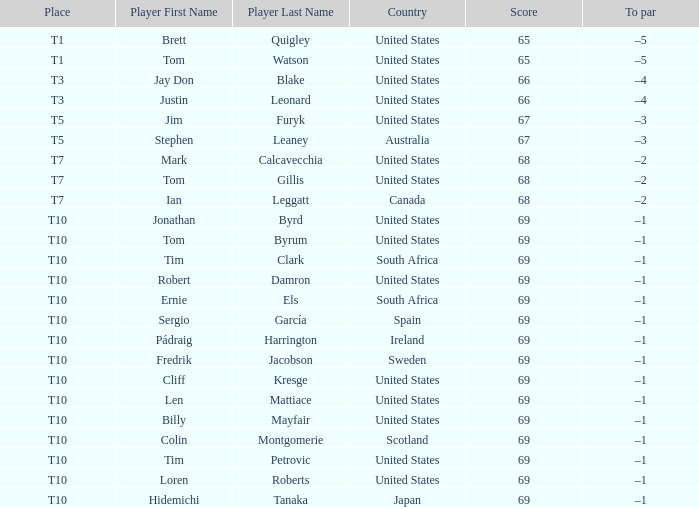Which player is T3? Jay Don Blake, Justin Leonard. 